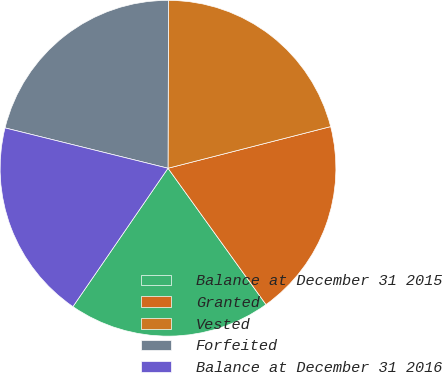<chart> <loc_0><loc_0><loc_500><loc_500><pie_chart><fcel>Balance at December 31 2015<fcel>Granted<fcel>Vested<fcel>Forfeited<fcel>Balance at December 31 2016<nl><fcel>19.5%<fcel>19.07%<fcel>20.96%<fcel>21.19%<fcel>19.28%<nl></chart> 